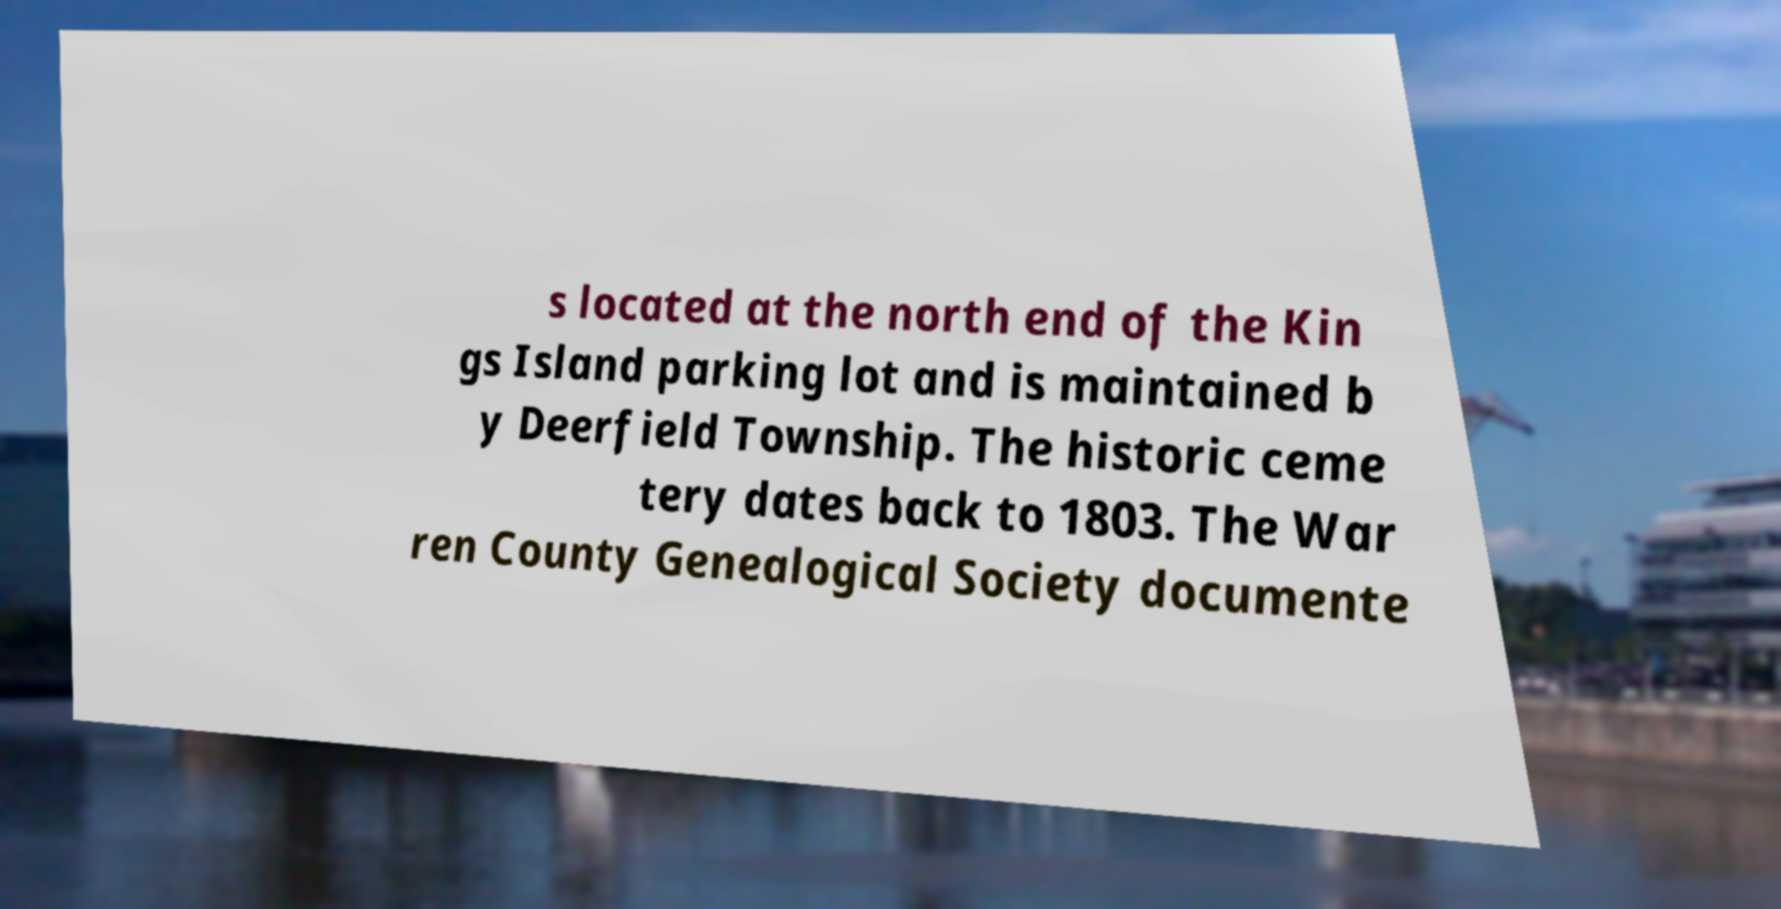Could you extract and type out the text from this image? s located at the north end of the Kin gs Island parking lot and is maintained b y Deerfield Township. The historic ceme tery dates back to 1803. The War ren County Genealogical Society documente 